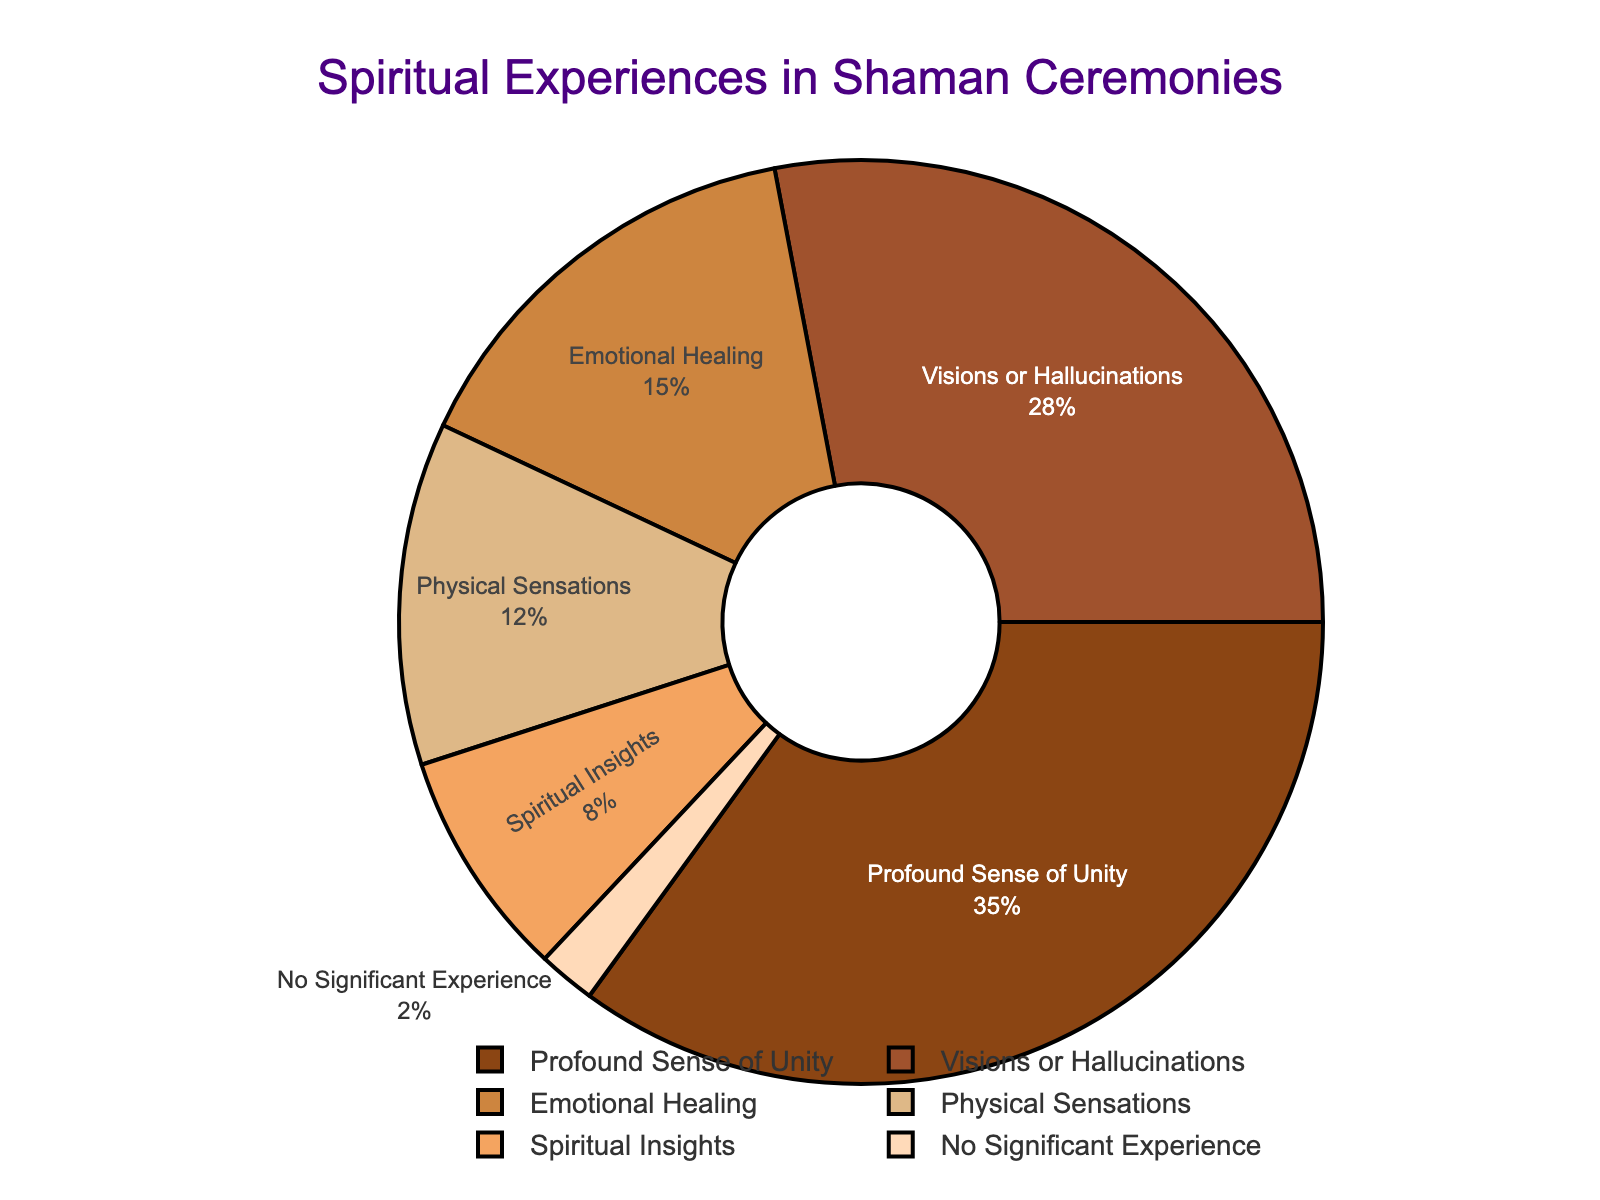What's the most frequently reported spiritual experience among ceremony attendees? The figure shows a pie chart with various spiritual experiences and their percentages. The largest section represents "Profound Sense of Unity" at 35%.
Answer: Profound Sense of Unity Which spiritual experience has the smallest percentage? The figure shows that the smallest section of the pie chart represents "No Significant Experience" at 2%.
Answer: No Significant Experience How many percentage points higher is the "Visions or Hallucinations" percentage compared to "Emotional Healing"? The "Visions or Hallucinations" percentage is 28% and the "Emotional Healing" percentage is 15%. The difference is 28 - 15 = 13 percentage points.
Answer: 13 What is the total percentage of attendees who reported either "Physical Sensations" or "Spiritual Insights"? The "Physical Sensations" percentage is 12% and the "Spiritual Insights" percentage is 8%. Their sum is 12 + 8 = 20%.
Answer: 20 How does the percentage of attendees reporting "Emotional Healing" compare with those reporting "Profound Sense of Unity"? The percentage for "Emotional Healing" is 15%, while for "Profound Sense of Unity" it is 35%. "Profound Sense of Unity" is 35 - 15 = 20 percentage points higher.
Answer: 20 What percentage of the reported experiences are transformative in nature (including "Emotional Healing" and "Spiritual Insights")? The percentages for "Emotional Healing" and "Spiritual Insights" are 15% and 8%, respectively. Combining them gives 15 + 8 = 23%.
Answer: 23 Which experience types together constitute more than half of the reported experiences? The experience types and their percentages are: "Profound Sense of Unity" (35%), "Visions or Hallucinations" (28%), "Emotional Healing" (15%), "Physical Sensations" (12%), "Spiritual Insights" (8%), and "No Significant Experience" (2%). Adding the percentages of "Profound Sense of Unity" and "Visions or Hallucinations" together results in 35 + 28 = 63%, which is more than half.
Answer: Profound Sense of Unity and Visions or Hallucinations 